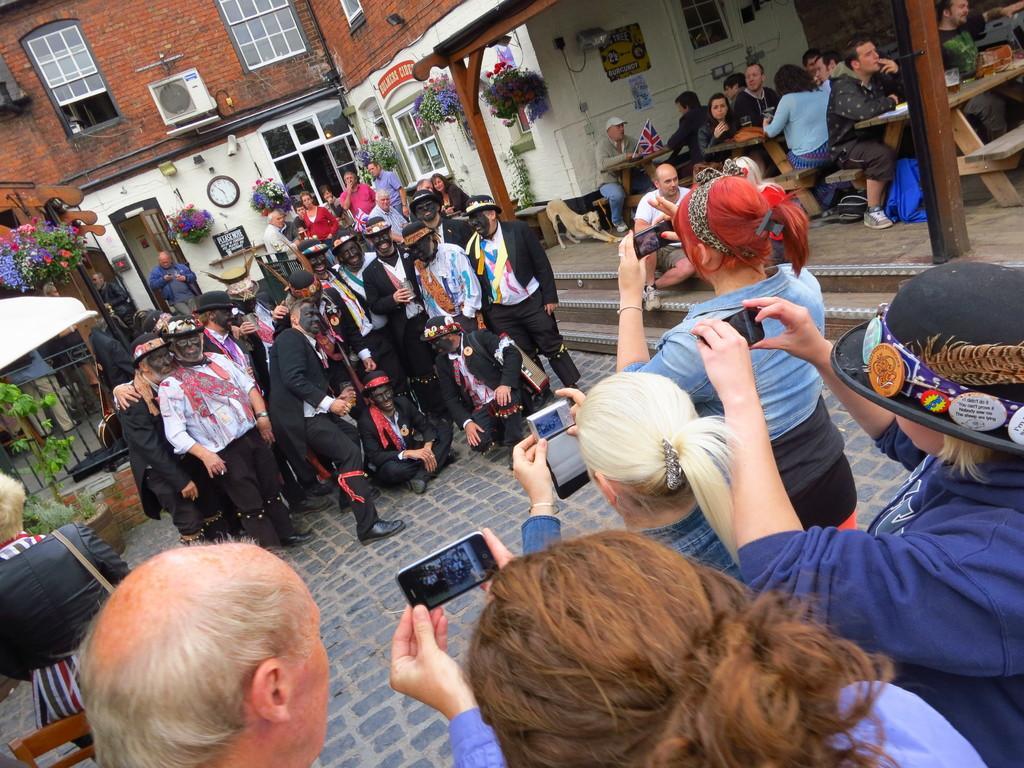How would you summarize this image in a sentence or two? Here in this picture, in the front we can see a group of people standing on the ground and clicking pictures with mobile phones in their hands and in front of them we can see number of people standing and sitting with some costumes and paint on their face and behind them also we can see other people standing and beside them we can see number of people sitting on benches with tables in front of them having food and we can see a building with windows and door on it and we can also see flower pots hanging over there and we can also see plants in the middle and we can see a clock in the middle. 